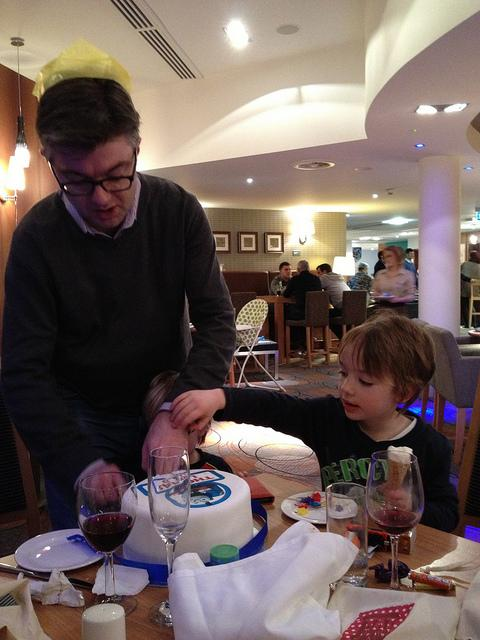Which person is likely celebrating a birthday? child 